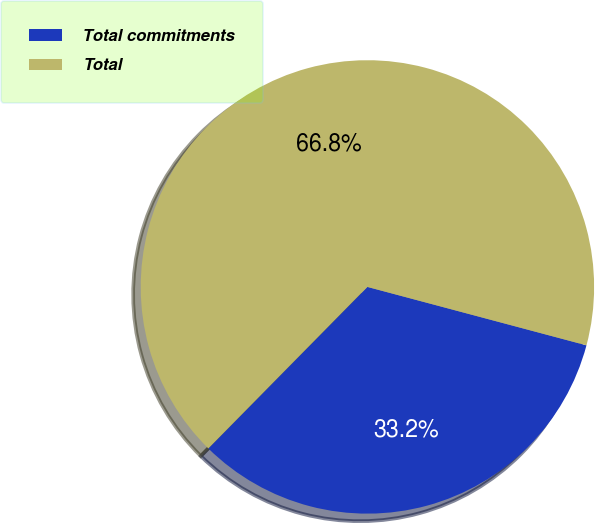Convert chart to OTSL. <chart><loc_0><loc_0><loc_500><loc_500><pie_chart><fcel>Total commitments<fcel>Total<nl><fcel>33.23%<fcel>66.77%<nl></chart> 